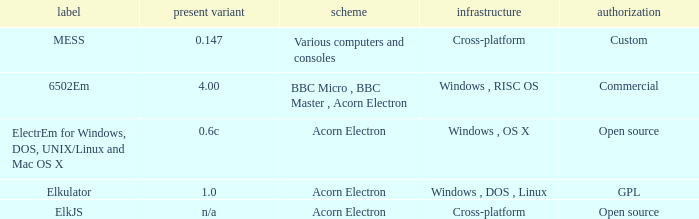What is the name of the platform used for various computers and consoles? Cross-platform. 